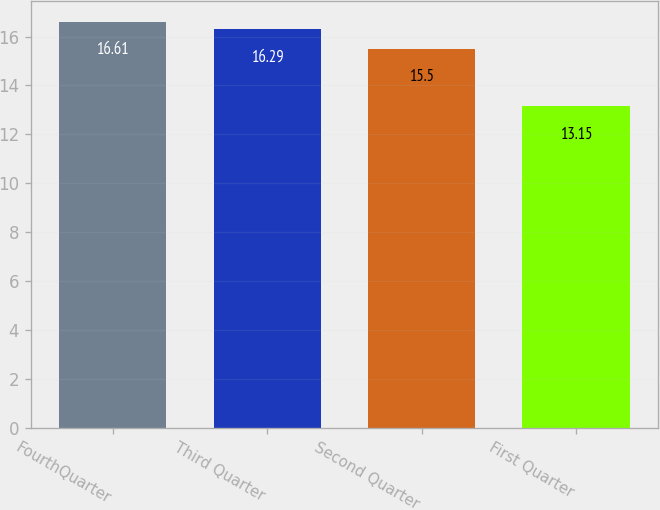Convert chart to OTSL. <chart><loc_0><loc_0><loc_500><loc_500><bar_chart><fcel>FourthQuarter<fcel>Third Quarter<fcel>Second Quarter<fcel>First Quarter<nl><fcel>16.61<fcel>16.29<fcel>15.5<fcel>13.15<nl></chart> 